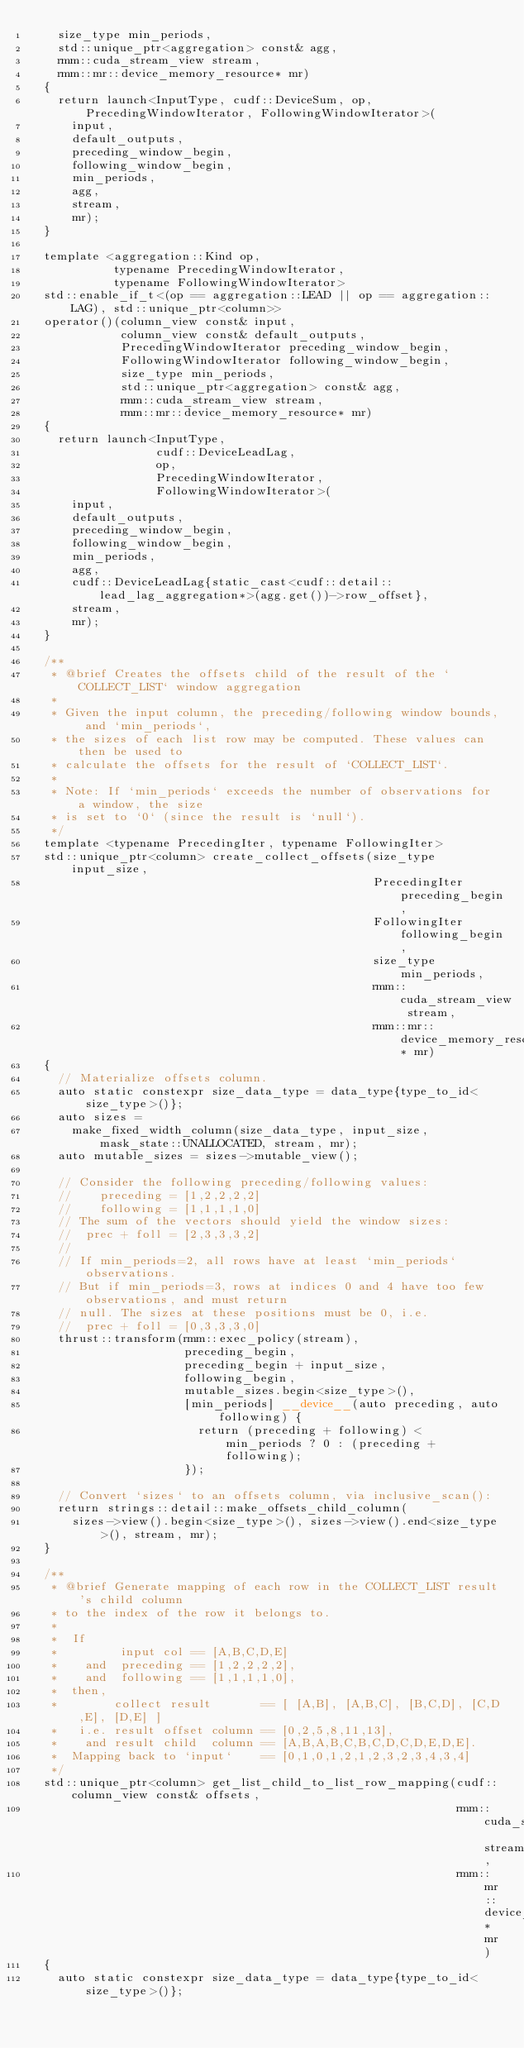Convert code to text. <code><loc_0><loc_0><loc_500><loc_500><_Cuda_>    size_type min_periods,
    std::unique_ptr<aggregation> const& agg,
    rmm::cuda_stream_view stream,
    rmm::mr::device_memory_resource* mr)
  {
    return launch<InputType, cudf::DeviceSum, op, PrecedingWindowIterator, FollowingWindowIterator>(
      input,
      default_outputs,
      preceding_window_begin,
      following_window_begin,
      min_periods,
      agg,
      stream,
      mr);
  }

  template <aggregation::Kind op,
            typename PrecedingWindowIterator,
            typename FollowingWindowIterator>
  std::enable_if_t<(op == aggregation::LEAD || op == aggregation::LAG), std::unique_ptr<column>>
  operator()(column_view const& input,
             column_view const& default_outputs,
             PrecedingWindowIterator preceding_window_begin,
             FollowingWindowIterator following_window_begin,
             size_type min_periods,
             std::unique_ptr<aggregation> const& agg,
             rmm::cuda_stream_view stream,
             rmm::mr::device_memory_resource* mr)
  {
    return launch<InputType,
                  cudf::DeviceLeadLag,
                  op,
                  PrecedingWindowIterator,
                  FollowingWindowIterator>(
      input,
      default_outputs,
      preceding_window_begin,
      following_window_begin,
      min_periods,
      agg,
      cudf::DeviceLeadLag{static_cast<cudf::detail::lead_lag_aggregation*>(agg.get())->row_offset},
      stream,
      mr);
  }

  /**
   * @brief Creates the offsets child of the result of the `COLLECT_LIST` window aggregation
   *
   * Given the input column, the preceding/following window bounds, and `min_periods`,
   * the sizes of each list row may be computed. These values can then be used to
   * calculate the offsets for the result of `COLLECT_LIST`.
   *
   * Note: If `min_periods` exceeds the number of observations for a window, the size
   * is set to `0` (since the result is `null`).
   */
  template <typename PrecedingIter, typename FollowingIter>
  std::unique_ptr<column> create_collect_offsets(size_type input_size,
                                                 PrecedingIter preceding_begin,
                                                 FollowingIter following_begin,
                                                 size_type min_periods,
                                                 rmm::cuda_stream_view stream,
                                                 rmm::mr::device_memory_resource* mr)
  {
    // Materialize offsets column.
    auto static constexpr size_data_type = data_type{type_to_id<size_type>()};
    auto sizes =
      make_fixed_width_column(size_data_type, input_size, mask_state::UNALLOCATED, stream, mr);
    auto mutable_sizes = sizes->mutable_view();

    // Consider the following preceding/following values:
    //    preceding = [1,2,2,2,2]
    //    following = [1,1,1,1,0]
    // The sum of the vectors should yield the window sizes:
    //  prec + foll = [2,3,3,3,2]
    //
    // If min_periods=2, all rows have at least `min_periods` observations.
    // But if min_periods=3, rows at indices 0 and 4 have too few observations, and must return
    // null. The sizes at these positions must be 0, i.e.
    //  prec + foll = [0,3,3,3,0]
    thrust::transform(rmm::exec_policy(stream),
                      preceding_begin,
                      preceding_begin + input_size,
                      following_begin,
                      mutable_sizes.begin<size_type>(),
                      [min_periods] __device__(auto preceding, auto following) {
                        return (preceding + following) < min_periods ? 0 : (preceding + following);
                      });

    // Convert `sizes` to an offsets column, via inclusive_scan():
    return strings::detail::make_offsets_child_column(
      sizes->view().begin<size_type>(), sizes->view().end<size_type>(), stream, mr);
  }

  /**
   * @brief Generate mapping of each row in the COLLECT_LIST result's child column
   * to the index of the row it belongs to.
   *
   *  If
   *         input col == [A,B,C,D,E]
   *    and  preceding == [1,2,2,2,2],
   *    and  following == [1,1,1,1,0],
   *  then,
   *        collect result       == [ [A,B], [A,B,C], [B,C,D], [C,D,E], [D,E] ]
   *   i.e. result offset column == [0,2,5,8,11,13],
   *    and result child  column == [A,B,A,B,C,B,C,D,C,D,E,D,E].
   *  Mapping back to `input`    == [0,1,0,1,2,1,2,3,2,3,4,3,4]
   */
  std::unique_ptr<column> get_list_child_to_list_row_mapping(cudf::column_view const& offsets,
                                                             rmm::cuda_stream_view stream,
                                                             rmm::mr::device_memory_resource* mr)
  {
    auto static constexpr size_data_type = data_type{type_to_id<size_type>()};
</code> 